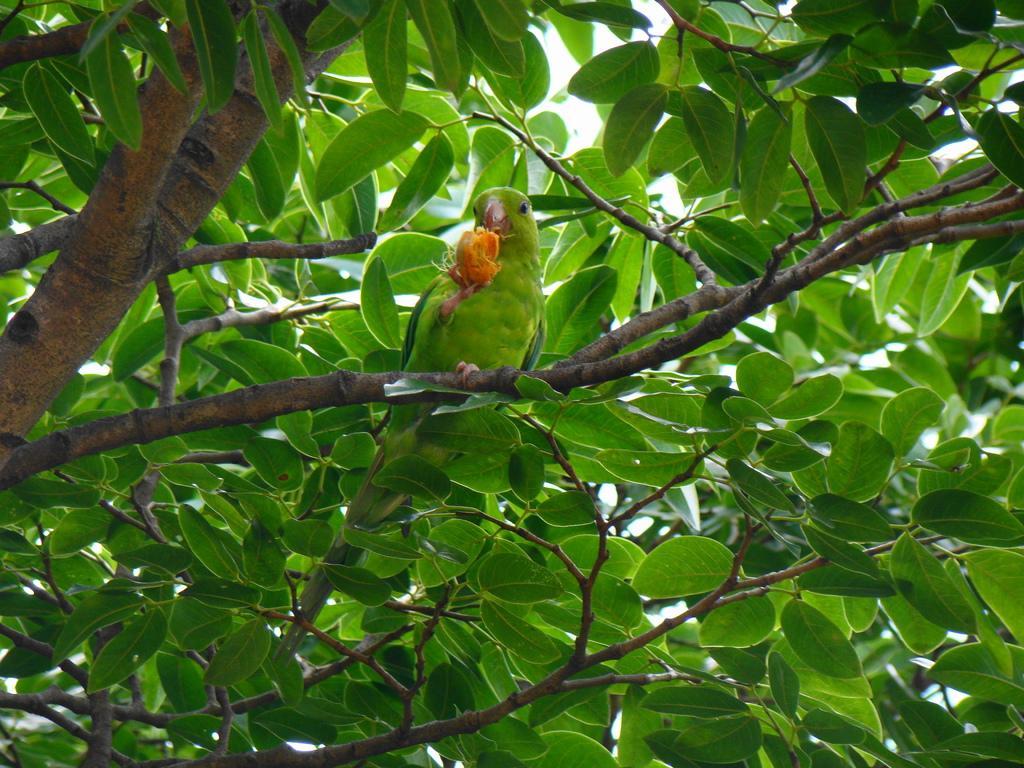Could you give a brief overview of what you see in this image? In this picture there is a parrot standing on a stem and holding an object and there are few leaves behind it. 